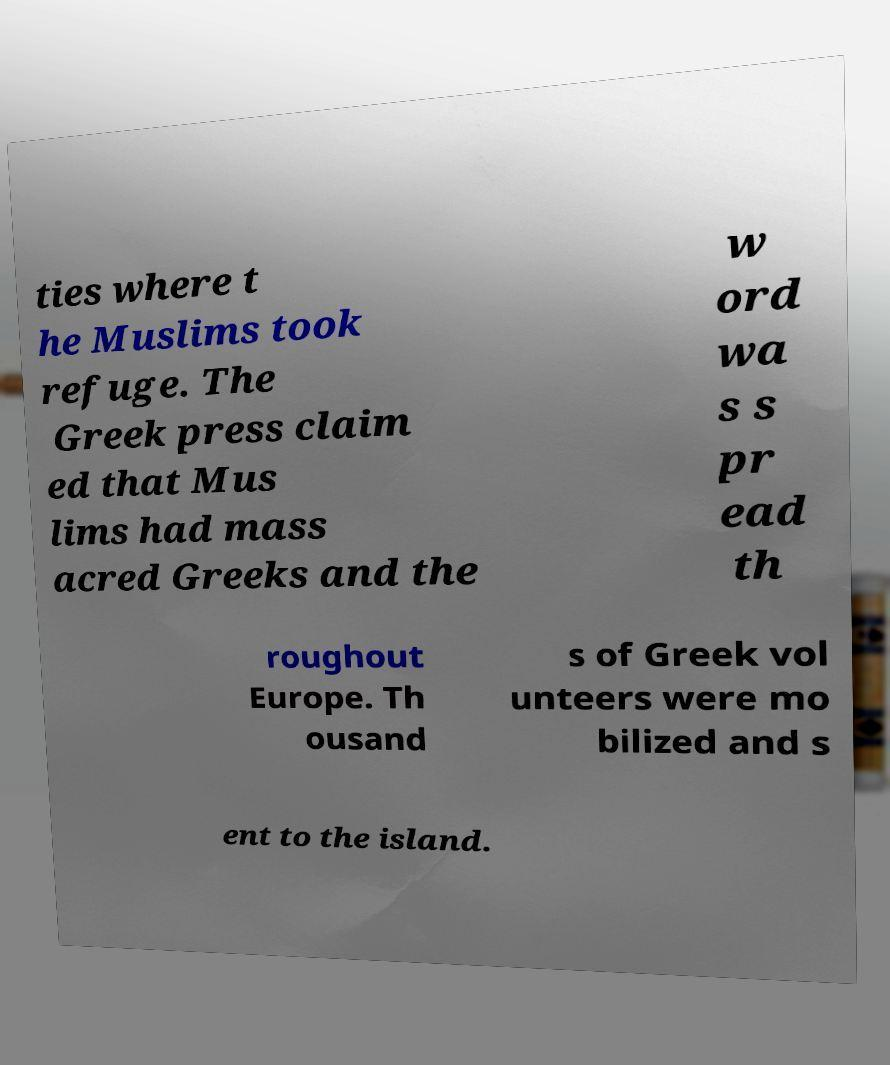Please read and relay the text visible in this image. What does it say? ties where t he Muslims took refuge. The Greek press claim ed that Mus lims had mass acred Greeks and the w ord wa s s pr ead th roughout Europe. Th ousand s of Greek vol unteers were mo bilized and s ent to the island. 